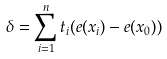Convert formula to latex. <formula><loc_0><loc_0><loc_500><loc_500>\delta = \sum _ { i = 1 } ^ { n } t _ { i } ( e ( x _ { i } ) - e ( x _ { 0 } ) )</formula> 